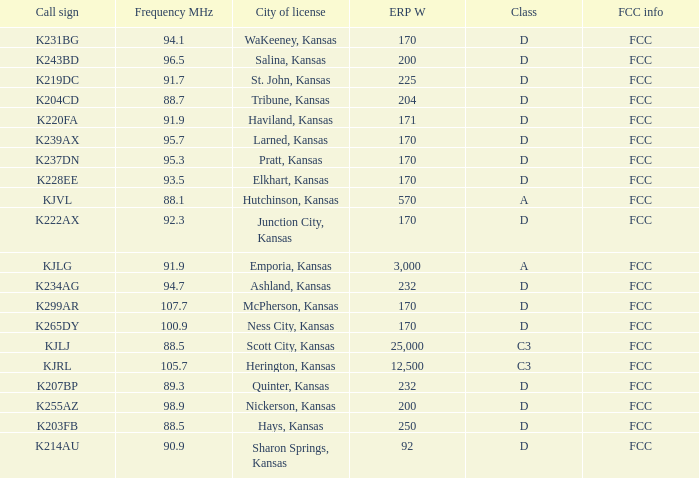Class of d, and a Frequency MHz smaller than 107.7, and a ERP W smaller than 232 has what call sign? K255AZ, K228EE, K220FA, K265DY, K237DN, K214AU, K222AX, K239AX, K243BD, K219DC, K204CD, K231BG. 